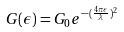<formula> <loc_0><loc_0><loc_500><loc_500>G ( \epsilon ) = G _ { 0 } e ^ { - ( \frac { 4 \pi \epsilon } { \lambda } ) ^ { 2 } }</formula> 